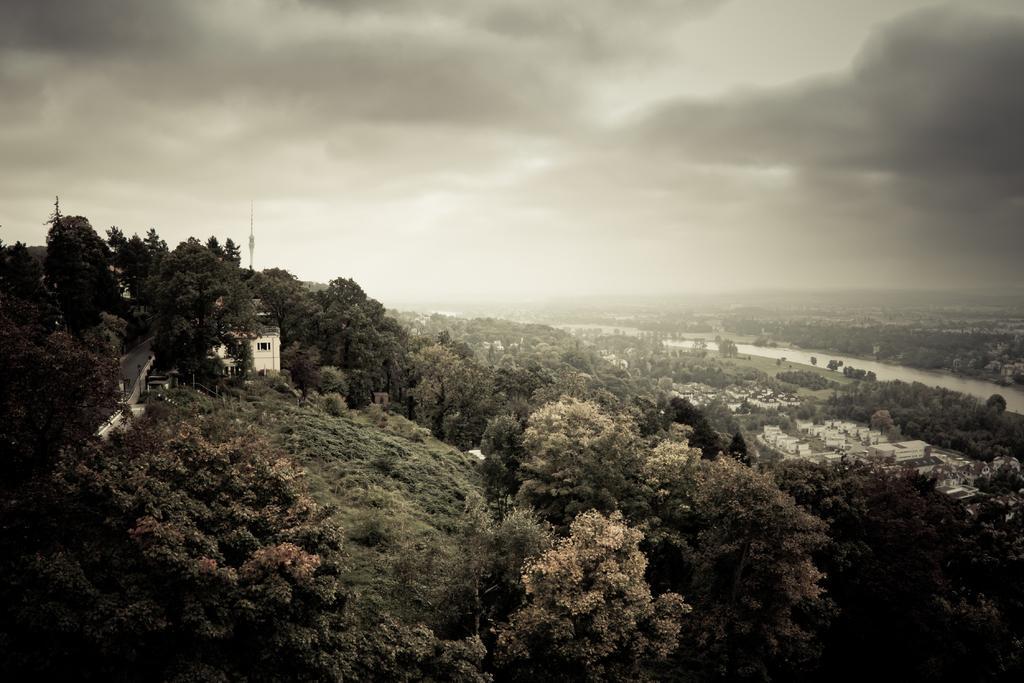Please provide a concise description of this image. In this picture there are houses on the right and left side of the image, there is greenery around the area of the image. 